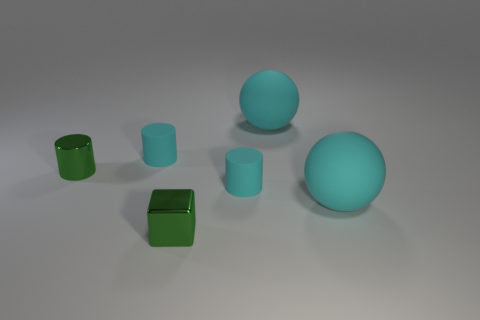What shape is the green object that is to the right of the green cylinder?
Keep it short and to the point. Cube. Is the material of the cube the same as the tiny green cylinder?
Provide a succinct answer. Yes. Is there anything else that has the same material as the green cube?
Your response must be concise. Yes. Is the number of green cylinders left of the tiny green shiny cylinder less than the number of large cyan spheres?
Ensure brevity in your answer.  Yes. There is a tiny green cylinder; how many green objects are right of it?
Offer a terse response. 1. Does the small cyan matte thing that is in front of the small green metallic cylinder have the same shape as the small green object to the left of the cube?
Offer a terse response. Yes. The rubber object that is both behind the green metallic cylinder and on the right side of the block has what shape?
Provide a short and direct response. Sphere. There is a green object that is made of the same material as the cube; what is its size?
Your answer should be compact. Small. Is the number of big cyan rubber spheres less than the number of purple matte cubes?
Give a very brief answer. No. There is a cyan ball behind the tiny cyan matte cylinder to the left of the tiny rubber cylinder to the right of the small green metallic cube; what is it made of?
Offer a very short reply. Rubber. 